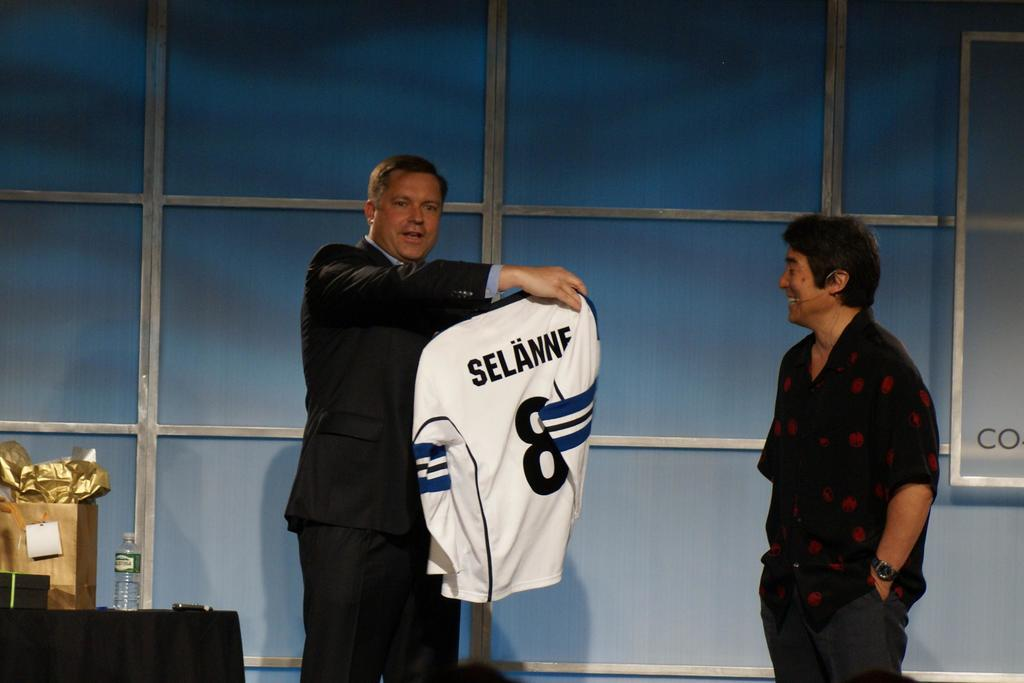<image>
Describe the image concisely. Man holding a white jersey that has the number 8 on it. 